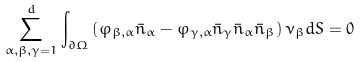Convert formula to latex. <formula><loc_0><loc_0><loc_500><loc_500>\sum _ { \alpha , \beta , \gamma = 1 } ^ { d } \int _ { \partial \Omega } \left ( \varphi _ { \beta , \alpha } \bar { n } _ { \alpha } - \varphi _ { \gamma , \alpha } \bar { n } _ { \gamma } \bar { n } _ { \alpha } \bar { n } _ { \beta } \right ) \nu _ { \beta } d S = 0</formula> 